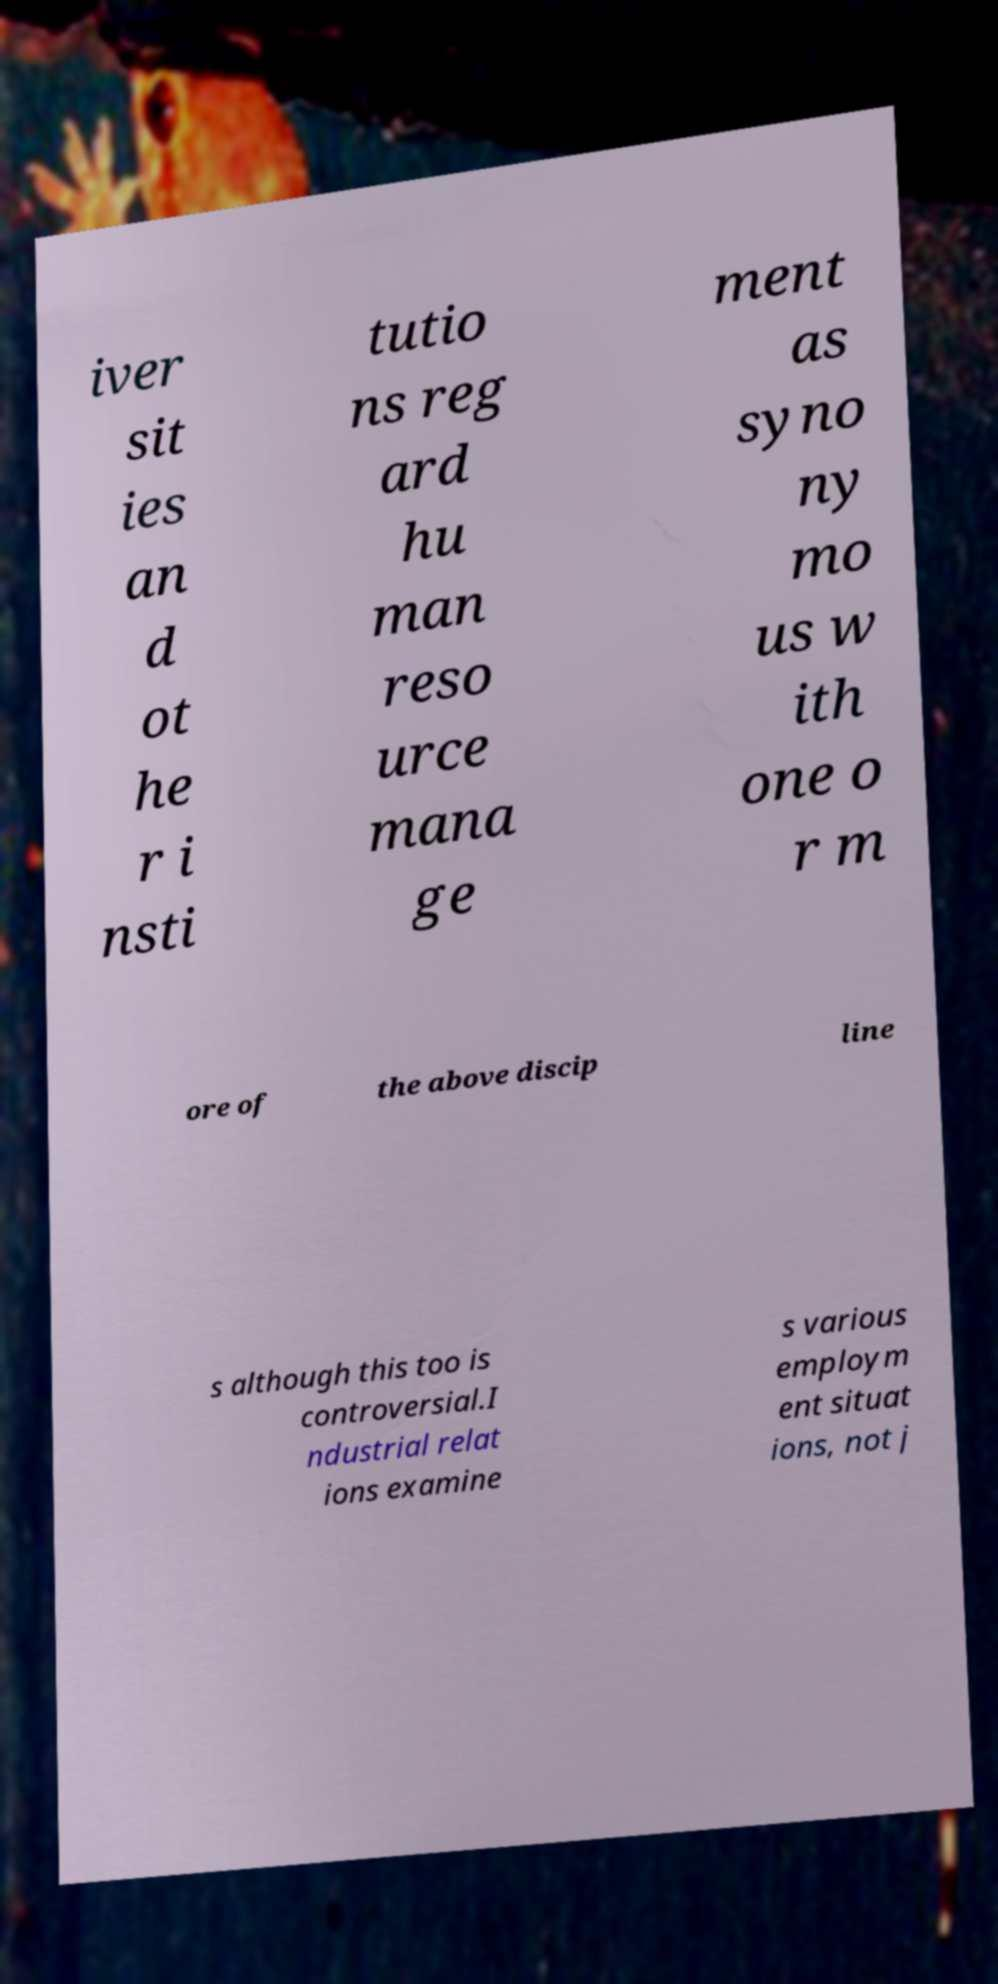What messages or text are displayed in this image? I need them in a readable, typed format. iver sit ies an d ot he r i nsti tutio ns reg ard hu man reso urce mana ge ment as syno ny mo us w ith one o r m ore of the above discip line s although this too is controversial.I ndustrial relat ions examine s various employm ent situat ions, not j 